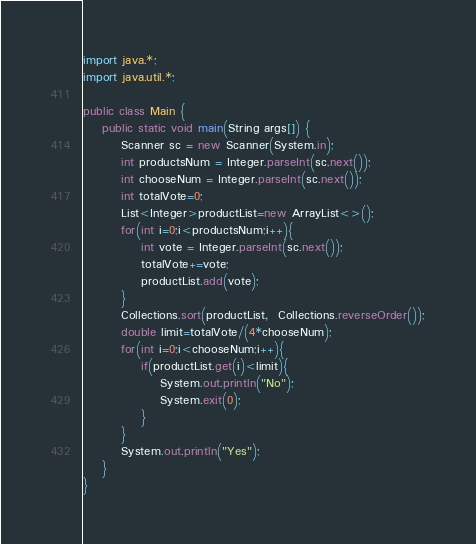Convert code to text. <code><loc_0><loc_0><loc_500><loc_500><_Java_>import java.*;
import java.util.*;
 
public class Main {
    public static void main(String args[]) {
        Scanner sc = new Scanner(System.in);
		int productsNum = Integer.parseInt(sc.next());
      	int chooseNum = Integer.parseInt(sc.next());
      	int totalVote=0;
      	List<Integer>productList=new ArrayList<>();
      	for(int i=0;i<productsNum;i++){
        	int vote = Integer.parseInt(sc.next());
          	totalVote+=vote;
          	productList.add(vote);
        }
      	Collections.sort(productList,  Collections.reverseOrder());
      	double limit=totalVote/(4*chooseNum);
      	for(int i=0;i<chooseNum;i++){
        	if(productList.get(i)<limit){
            	System.out.println("No");
              	System.exit(0);
            }
        }
      	System.out.println("Yes");
    }
}</code> 